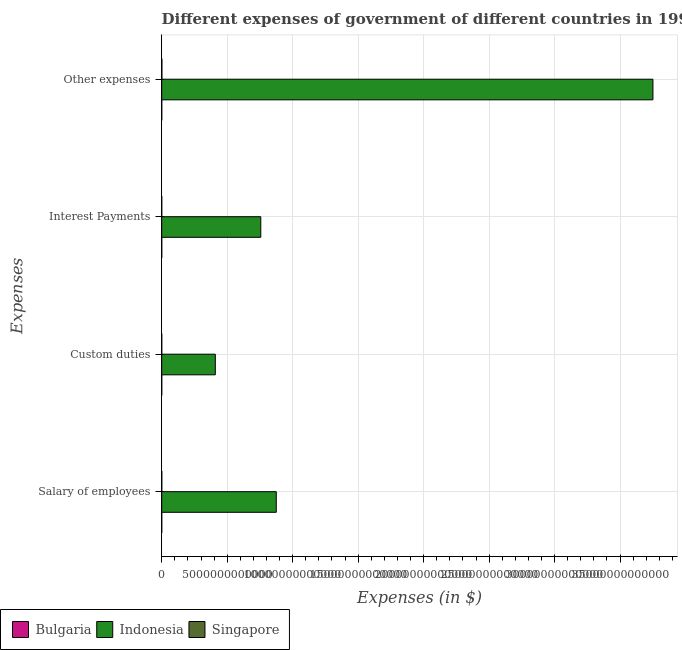How many different coloured bars are there?
Provide a succinct answer. 3. How many groups of bars are there?
Your answer should be compact. 4. Are the number of bars on each tick of the Y-axis equal?
Keep it short and to the point. Yes. How many bars are there on the 1st tick from the top?
Keep it short and to the point. 3. How many bars are there on the 2nd tick from the bottom?
Make the answer very short. 3. What is the label of the 4th group of bars from the top?
Ensure brevity in your answer.  Salary of employees. What is the amount spent on salary of employees in Singapore?
Your answer should be compact. 5.40e+09. Across all countries, what is the maximum amount spent on salary of employees?
Offer a terse response. 8.75e+12. Across all countries, what is the minimum amount spent on other expenses?
Offer a very short reply. 2.30e+08. In which country was the amount spent on interest payments minimum?
Offer a terse response. Bulgaria. What is the total amount spent on salary of employees in the graph?
Make the answer very short. 8.75e+12. What is the difference between the amount spent on custom duties in Singapore and that in Bulgaria?
Your response must be concise. 3.83e+08. What is the difference between the amount spent on salary of employees in Singapore and the amount spent on interest payments in Bulgaria?
Your response must be concise. 5.33e+09. What is the average amount spent on other expenses per country?
Provide a short and direct response. 1.25e+13. What is the difference between the amount spent on salary of employees and amount spent on custom duties in Bulgaria?
Your answer should be very brief. 1.18e+06. What is the ratio of the amount spent on custom duties in Indonesia to that in Singapore?
Your answer should be very brief. 1.04e+04. Is the difference between the amount spent on salary of employees in Indonesia and Singapore greater than the difference between the amount spent on other expenses in Indonesia and Singapore?
Keep it short and to the point. No. What is the difference between the highest and the second highest amount spent on interest payments?
Offer a very short reply. 7.56e+12. What is the difference between the highest and the lowest amount spent on interest payments?
Offer a very short reply. 7.56e+12. In how many countries, is the amount spent on interest payments greater than the average amount spent on interest payments taken over all countries?
Your answer should be compact. 1. Is it the case that in every country, the sum of the amount spent on interest payments and amount spent on salary of employees is greater than the sum of amount spent on other expenses and amount spent on custom duties?
Ensure brevity in your answer.  No. What does the 1st bar from the bottom in Salary of employees represents?
Give a very brief answer. Bulgaria. Are all the bars in the graph horizontal?
Your answer should be compact. Yes. How many countries are there in the graph?
Offer a very short reply. 3. What is the difference between two consecutive major ticks on the X-axis?
Your response must be concise. 5.00e+12. Are the values on the major ticks of X-axis written in scientific E-notation?
Your answer should be compact. No. Where does the legend appear in the graph?
Ensure brevity in your answer.  Bottom left. How many legend labels are there?
Offer a terse response. 3. How are the legend labels stacked?
Keep it short and to the point. Horizontal. What is the title of the graph?
Offer a terse response. Different expenses of government of different countries in 1994. Does "Zambia" appear as one of the legend labels in the graph?
Offer a terse response. No. What is the label or title of the X-axis?
Provide a short and direct response. Expenses (in $). What is the label or title of the Y-axis?
Give a very brief answer. Expenses. What is the Expenses (in $) of Bulgaria in Salary of employees?
Offer a terse response. 1.36e+07. What is the Expenses (in $) of Indonesia in Salary of employees?
Your answer should be compact. 8.75e+12. What is the Expenses (in $) in Singapore in Salary of employees?
Your answer should be very brief. 5.40e+09. What is the Expenses (in $) of Bulgaria in Custom duties?
Your answer should be compact. 1.24e+07. What is the Expenses (in $) of Indonesia in Custom duties?
Keep it short and to the point. 4.09e+12. What is the Expenses (in $) of Singapore in Custom duties?
Your answer should be very brief. 3.95e+08. What is the Expenses (in $) in Bulgaria in Interest Payments?
Offer a very short reply. 7.64e+07. What is the Expenses (in $) in Indonesia in Interest Payments?
Your answer should be compact. 7.56e+12. What is the Expenses (in $) of Singapore in Interest Payments?
Ensure brevity in your answer.  1.14e+09. What is the Expenses (in $) in Bulgaria in Other expenses?
Provide a succinct answer. 2.30e+08. What is the Expenses (in $) in Indonesia in Other expenses?
Offer a very short reply. 3.75e+13. What is the Expenses (in $) in Singapore in Other expenses?
Make the answer very short. 1.23e+1. Across all Expenses, what is the maximum Expenses (in $) in Bulgaria?
Offer a terse response. 2.30e+08. Across all Expenses, what is the maximum Expenses (in $) of Indonesia?
Provide a succinct answer. 3.75e+13. Across all Expenses, what is the maximum Expenses (in $) in Singapore?
Keep it short and to the point. 1.23e+1. Across all Expenses, what is the minimum Expenses (in $) of Bulgaria?
Give a very brief answer. 1.24e+07. Across all Expenses, what is the minimum Expenses (in $) of Indonesia?
Your answer should be very brief. 4.09e+12. Across all Expenses, what is the minimum Expenses (in $) in Singapore?
Provide a short and direct response. 3.95e+08. What is the total Expenses (in $) in Bulgaria in the graph?
Give a very brief answer. 3.32e+08. What is the total Expenses (in $) in Indonesia in the graph?
Your answer should be very brief. 5.79e+13. What is the total Expenses (in $) of Singapore in the graph?
Give a very brief answer. 1.92e+1. What is the difference between the Expenses (in $) of Bulgaria in Salary of employees and that in Custom duties?
Give a very brief answer. 1.18e+06. What is the difference between the Expenses (in $) of Indonesia in Salary of employees and that in Custom duties?
Your answer should be compact. 4.66e+12. What is the difference between the Expenses (in $) of Singapore in Salary of employees and that in Custom duties?
Give a very brief answer. 5.01e+09. What is the difference between the Expenses (in $) of Bulgaria in Salary of employees and that in Interest Payments?
Your answer should be compact. -6.28e+07. What is the difference between the Expenses (in $) of Indonesia in Salary of employees and that in Interest Payments?
Keep it short and to the point. 1.18e+12. What is the difference between the Expenses (in $) of Singapore in Salary of employees and that in Interest Payments?
Your response must be concise. 4.27e+09. What is the difference between the Expenses (in $) in Bulgaria in Salary of employees and that in Other expenses?
Offer a very short reply. -2.16e+08. What is the difference between the Expenses (in $) in Indonesia in Salary of employees and that in Other expenses?
Your answer should be very brief. -2.88e+13. What is the difference between the Expenses (in $) of Singapore in Salary of employees and that in Other expenses?
Make the answer very short. -6.88e+09. What is the difference between the Expenses (in $) in Bulgaria in Custom duties and that in Interest Payments?
Your response must be concise. -6.40e+07. What is the difference between the Expenses (in $) of Indonesia in Custom duties and that in Interest Payments?
Keep it short and to the point. -3.47e+12. What is the difference between the Expenses (in $) of Singapore in Custom duties and that in Interest Payments?
Your response must be concise. -7.41e+08. What is the difference between the Expenses (in $) of Bulgaria in Custom duties and that in Other expenses?
Offer a very short reply. -2.17e+08. What is the difference between the Expenses (in $) in Indonesia in Custom duties and that in Other expenses?
Provide a succinct answer. -3.34e+13. What is the difference between the Expenses (in $) of Singapore in Custom duties and that in Other expenses?
Give a very brief answer. -1.19e+1. What is the difference between the Expenses (in $) in Bulgaria in Interest Payments and that in Other expenses?
Offer a terse response. -1.53e+08. What is the difference between the Expenses (in $) in Indonesia in Interest Payments and that in Other expenses?
Provide a succinct answer. -2.99e+13. What is the difference between the Expenses (in $) in Singapore in Interest Payments and that in Other expenses?
Keep it short and to the point. -1.12e+1. What is the difference between the Expenses (in $) of Bulgaria in Salary of employees and the Expenses (in $) of Indonesia in Custom duties?
Your answer should be compact. -4.09e+12. What is the difference between the Expenses (in $) of Bulgaria in Salary of employees and the Expenses (in $) of Singapore in Custom duties?
Ensure brevity in your answer.  -3.81e+08. What is the difference between the Expenses (in $) in Indonesia in Salary of employees and the Expenses (in $) in Singapore in Custom duties?
Provide a short and direct response. 8.75e+12. What is the difference between the Expenses (in $) in Bulgaria in Salary of employees and the Expenses (in $) in Indonesia in Interest Payments?
Offer a terse response. -7.56e+12. What is the difference between the Expenses (in $) of Bulgaria in Salary of employees and the Expenses (in $) of Singapore in Interest Payments?
Offer a very short reply. -1.12e+09. What is the difference between the Expenses (in $) in Indonesia in Salary of employees and the Expenses (in $) in Singapore in Interest Payments?
Your response must be concise. 8.75e+12. What is the difference between the Expenses (in $) in Bulgaria in Salary of employees and the Expenses (in $) in Indonesia in Other expenses?
Keep it short and to the point. -3.75e+13. What is the difference between the Expenses (in $) in Bulgaria in Salary of employees and the Expenses (in $) in Singapore in Other expenses?
Provide a short and direct response. -1.23e+1. What is the difference between the Expenses (in $) in Indonesia in Salary of employees and the Expenses (in $) in Singapore in Other expenses?
Give a very brief answer. 8.74e+12. What is the difference between the Expenses (in $) of Bulgaria in Custom duties and the Expenses (in $) of Indonesia in Interest Payments?
Your response must be concise. -7.56e+12. What is the difference between the Expenses (in $) in Bulgaria in Custom duties and the Expenses (in $) in Singapore in Interest Payments?
Ensure brevity in your answer.  -1.12e+09. What is the difference between the Expenses (in $) in Indonesia in Custom duties and the Expenses (in $) in Singapore in Interest Payments?
Your answer should be compact. 4.09e+12. What is the difference between the Expenses (in $) in Bulgaria in Custom duties and the Expenses (in $) in Indonesia in Other expenses?
Your answer should be compact. -3.75e+13. What is the difference between the Expenses (in $) of Bulgaria in Custom duties and the Expenses (in $) of Singapore in Other expenses?
Ensure brevity in your answer.  -1.23e+1. What is the difference between the Expenses (in $) in Indonesia in Custom duties and the Expenses (in $) in Singapore in Other expenses?
Your answer should be very brief. 4.08e+12. What is the difference between the Expenses (in $) in Bulgaria in Interest Payments and the Expenses (in $) in Indonesia in Other expenses?
Provide a short and direct response. -3.75e+13. What is the difference between the Expenses (in $) in Bulgaria in Interest Payments and the Expenses (in $) in Singapore in Other expenses?
Give a very brief answer. -1.22e+1. What is the difference between the Expenses (in $) of Indonesia in Interest Payments and the Expenses (in $) of Singapore in Other expenses?
Your answer should be very brief. 7.55e+12. What is the average Expenses (in $) of Bulgaria per Expenses?
Your answer should be very brief. 8.31e+07. What is the average Expenses (in $) of Indonesia per Expenses?
Give a very brief answer. 1.45e+13. What is the average Expenses (in $) in Singapore per Expenses?
Your response must be concise. 4.81e+09. What is the difference between the Expenses (in $) of Bulgaria and Expenses (in $) of Indonesia in Salary of employees?
Keep it short and to the point. -8.75e+12. What is the difference between the Expenses (in $) of Bulgaria and Expenses (in $) of Singapore in Salary of employees?
Provide a succinct answer. -5.39e+09. What is the difference between the Expenses (in $) of Indonesia and Expenses (in $) of Singapore in Salary of employees?
Give a very brief answer. 8.74e+12. What is the difference between the Expenses (in $) of Bulgaria and Expenses (in $) of Indonesia in Custom duties?
Your answer should be very brief. -4.09e+12. What is the difference between the Expenses (in $) of Bulgaria and Expenses (in $) of Singapore in Custom duties?
Your answer should be compact. -3.83e+08. What is the difference between the Expenses (in $) of Indonesia and Expenses (in $) of Singapore in Custom duties?
Keep it short and to the point. 4.09e+12. What is the difference between the Expenses (in $) of Bulgaria and Expenses (in $) of Indonesia in Interest Payments?
Ensure brevity in your answer.  -7.56e+12. What is the difference between the Expenses (in $) of Bulgaria and Expenses (in $) of Singapore in Interest Payments?
Offer a terse response. -1.06e+09. What is the difference between the Expenses (in $) in Indonesia and Expenses (in $) in Singapore in Interest Payments?
Offer a very short reply. 7.56e+12. What is the difference between the Expenses (in $) in Bulgaria and Expenses (in $) in Indonesia in Other expenses?
Offer a terse response. -3.75e+13. What is the difference between the Expenses (in $) of Bulgaria and Expenses (in $) of Singapore in Other expenses?
Give a very brief answer. -1.21e+1. What is the difference between the Expenses (in $) of Indonesia and Expenses (in $) of Singapore in Other expenses?
Keep it short and to the point. 3.75e+13. What is the ratio of the Expenses (in $) in Bulgaria in Salary of employees to that in Custom duties?
Make the answer very short. 1.1. What is the ratio of the Expenses (in $) of Indonesia in Salary of employees to that in Custom duties?
Give a very brief answer. 2.14. What is the ratio of the Expenses (in $) in Singapore in Salary of employees to that in Custom duties?
Keep it short and to the point. 13.68. What is the ratio of the Expenses (in $) of Bulgaria in Salary of employees to that in Interest Payments?
Offer a terse response. 0.18. What is the ratio of the Expenses (in $) of Indonesia in Salary of employees to that in Interest Payments?
Your answer should be very brief. 1.16. What is the ratio of the Expenses (in $) in Singapore in Salary of employees to that in Interest Payments?
Provide a short and direct response. 4.76. What is the ratio of the Expenses (in $) in Bulgaria in Salary of employees to that in Other expenses?
Offer a terse response. 0.06. What is the ratio of the Expenses (in $) in Indonesia in Salary of employees to that in Other expenses?
Give a very brief answer. 0.23. What is the ratio of the Expenses (in $) in Singapore in Salary of employees to that in Other expenses?
Provide a short and direct response. 0.44. What is the ratio of the Expenses (in $) of Bulgaria in Custom duties to that in Interest Payments?
Provide a short and direct response. 0.16. What is the ratio of the Expenses (in $) of Indonesia in Custom duties to that in Interest Payments?
Your response must be concise. 0.54. What is the ratio of the Expenses (in $) in Singapore in Custom duties to that in Interest Payments?
Give a very brief answer. 0.35. What is the ratio of the Expenses (in $) of Bulgaria in Custom duties to that in Other expenses?
Provide a succinct answer. 0.05. What is the ratio of the Expenses (in $) of Indonesia in Custom duties to that in Other expenses?
Your answer should be compact. 0.11. What is the ratio of the Expenses (in $) of Singapore in Custom duties to that in Other expenses?
Give a very brief answer. 0.03. What is the ratio of the Expenses (in $) of Bulgaria in Interest Payments to that in Other expenses?
Give a very brief answer. 0.33. What is the ratio of the Expenses (in $) in Indonesia in Interest Payments to that in Other expenses?
Your answer should be compact. 0.2. What is the ratio of the Expenses (in $) in Singapore in Interest Payments to that in Other expenses?
Make the answer very short. 0.09. What is the difference between the highest and the second highest Expenses (in $) of Bulgaria?
Make the answer very short. 1.53e+08. What is the difference between the highest and the second highest Expenses (in $) in Indonesia?
Provide a succinct answer. 2.88e+13. What is the difference between the highest and the second highest Expenses (in $) in Singapore?
Your answer should be very brief. 6.88e+09. What is the difference between the highest and the lowest Expenses (in $) of Bulgaria?
Offer a very short reply. 2.17e+08. What is the difference between the highest and the lowest Expenses (in $) in Indonesia?
Ensure brevity in your answer.  3.34e+13. What is the difference between the highest and the lowest Expenses (in $) of Singapore?
Your answer should be very brief. 1.19e+1. 